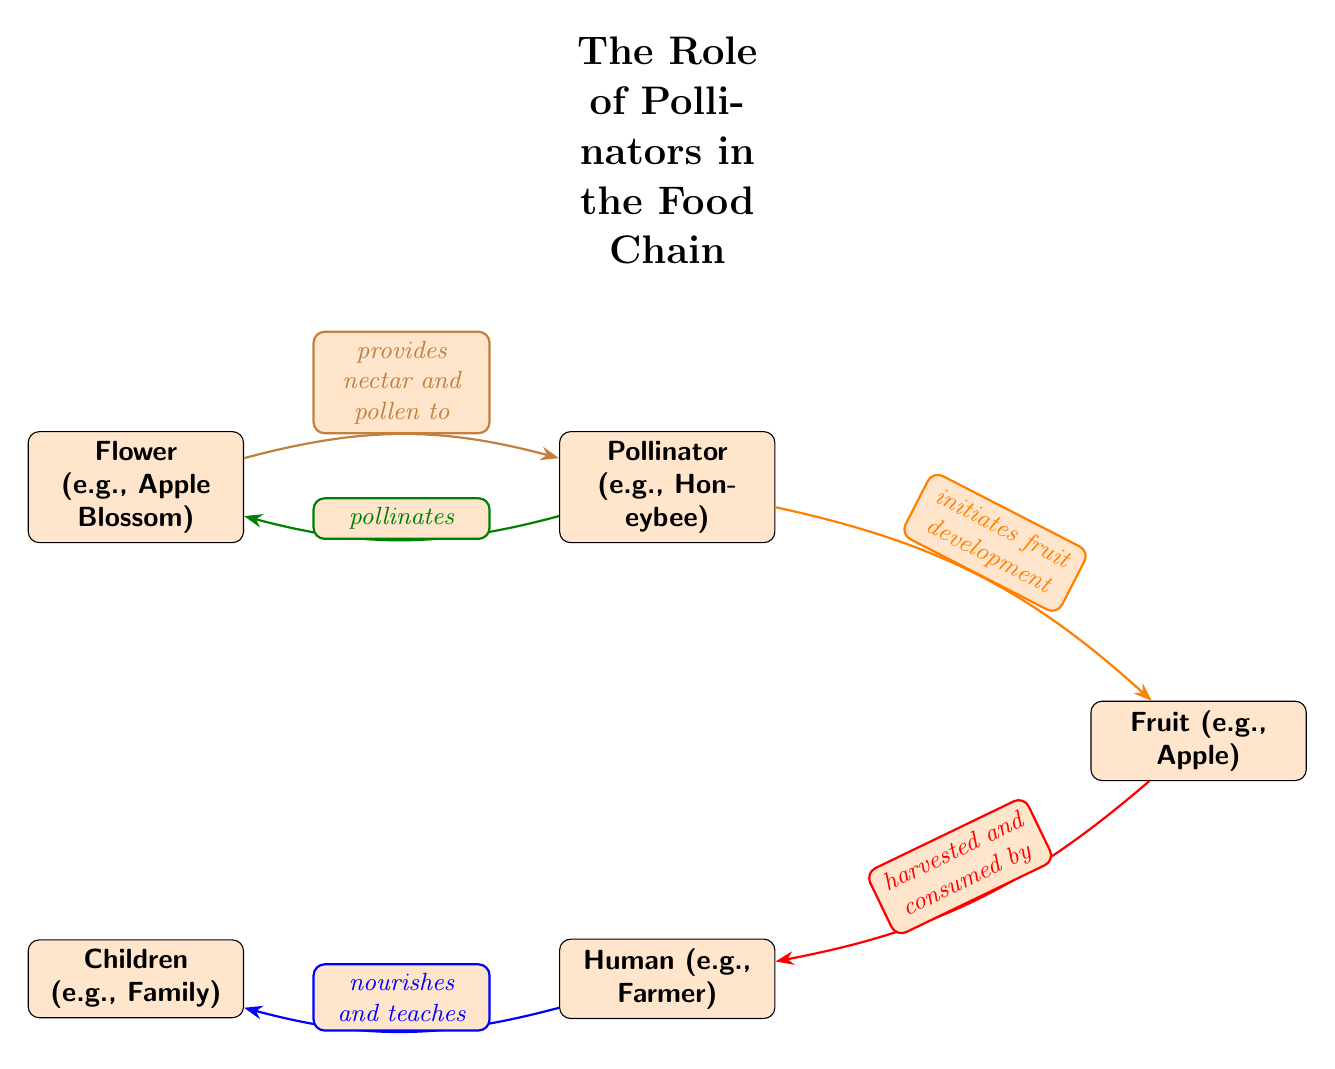What is the first node in the food chain? The first node is the Flower, as it is positioned at the top of the diagram.
Answer: Flower (e.g., Apple Blossom) How many nodes are in the food chain? The diagram contains five nodes: Flower, Pollinator, Fruit, Human, and Children.
Answer: 5 Who pollinates the flower? The Pollinator, specifically the Honeybee, is indicated as the one that pollinates the flower in the diagram.
Answer: Pollinator (e.g., Honeybee) What does the pollinator provide to the flower? The diagram shows that the pollinator provides nectar and pollen to the flower, indicating the resource it offers.
Answer: Nectar and pollen What role does the fruit play in the food chain? The fruit, exemplified by the apple, is shown as the result of the pollinator's action, which begins fruit development.
Answer: Initiates fruit development Which node is directly consumed by humans? According to the diagram, the Fruit is the aliment that humans consume.
Answer: Fruit (e.g., Apple) How does the human contribute to the food chain? The human is shown to nourish and teach the children, indicating their role in the food chain beyond consumption.
Answer: Nourishes and teaches What connection exists between the flower and the pollinator? The diagram depicts a reciprocal relationship where the flower provides nectar and pollen to the pollinator, while the pollinator also pollinates the flower.
Answer: Provides nectar and pollen to What is the last node in the food chain? The last node is Children, which represent the final position in the chain, receiving nourishment and lessons from humans.
Answer: Children (e.g., Family) What initiates fruit development in the food chain? The diagram indicates that the Pollinator, through its actions, initiates fruit development.
Answer: Pollinator (e.g., Honeybee) 